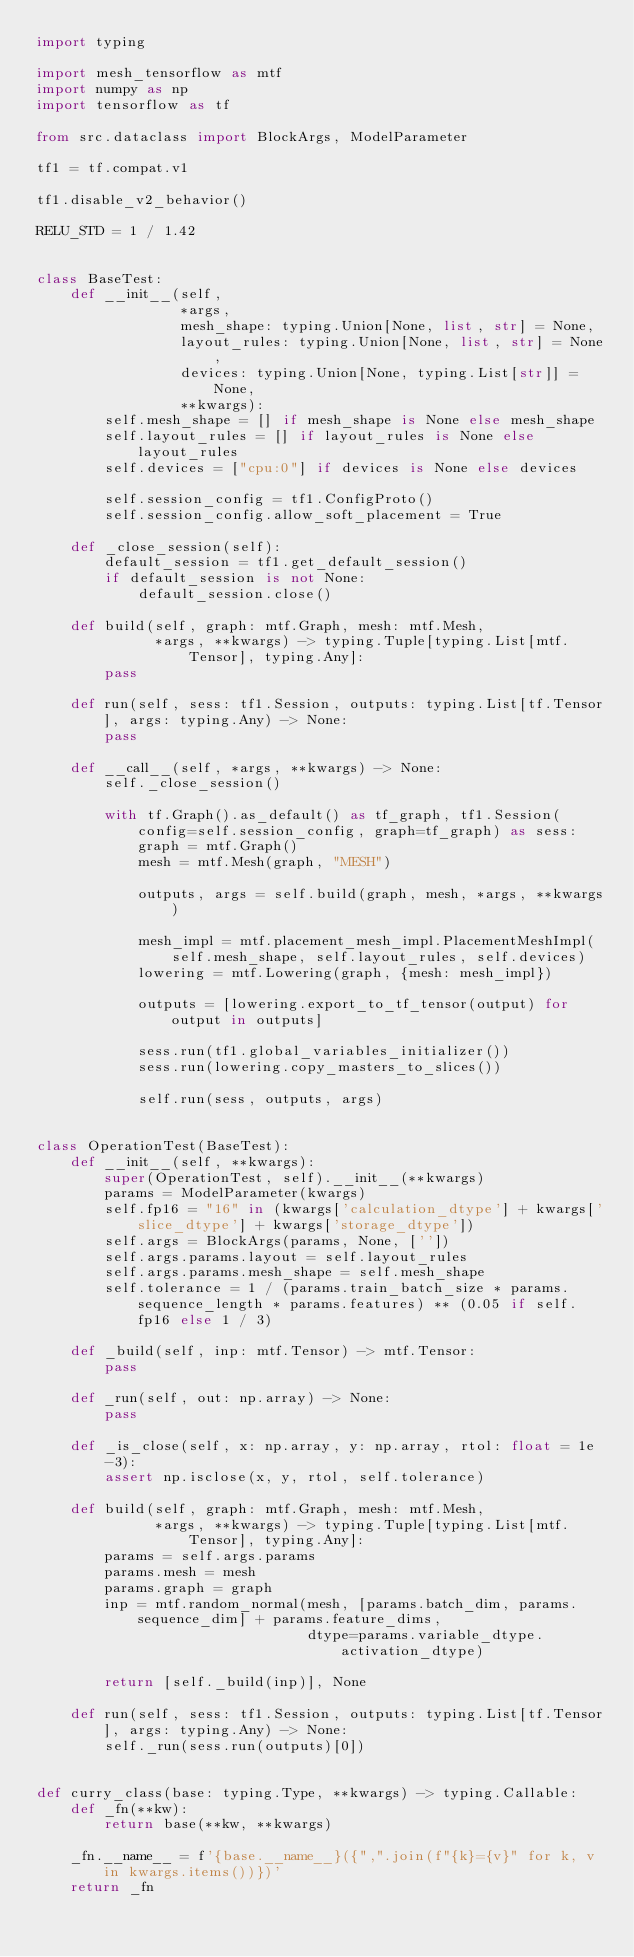<code> <loc_0><loc_0><loc_500><loc_500><_Python_>import typing

import mesh_tensorflow as mtf
import numpy as np
import tensorflow as tf

from src.dataclass import BlockArgs, ModelParameter

tf1 = tf.compat.v1

tf1.disable_v2_behavior()

RELU_STD = 1 / 1.42


class BaseTest:
    def __init__(self,
                 *args,
                 mesh_shape: typing.Union[None, list, str] = None,
                 layout_rules: typing.Union[None, list, str] = None,
                 devices: typing.Union[None, typing.List[str]] = None,
                 **kwargs):
        self.mesh_shape = [] if mesh_shape is None else mesh_shape
        self.layout_rules = [] if layout_rules is None else layout_rules
        self.devices = ["cpu:0"] if devices is None else devices

        self.session_config = tf1.ConfigProto()
        self.session_config.allow_soft_placement = True

    def _close_session(self):
        default_session = tf1.get_default_session()
        if default_session is not None:
            default_session.close()

    def build(self, graph: mtf.Graph, mesh: mtf.Mesh,
              *args, **kwargs) -> typing.Tuple[typing.List[mtf.Tensor], typing.Any]:
        pass

    def run(self, sess: tf1.Session, outputs: typing.List[tf.Tensor], args: typing.Any) -> None:
        pass

    def __call__(self, *args, **kwargs) -> None:
        self._close_session()

        with tf.Graph().as_default() as tf_graph, tf1.Session(config=self.session_config, graph=tf_graph) as sess:
            graph = mtf.Graph()
            mesh = mtf.Mesh(graph, "MESH")

            outputs, args = self.build(graph, mesh, *args, **kwargs)

            mesh_impl = mtf.placement_mesh_impl.PlacementMeshImpl(self.mesh_shape, self.layout_rules, self.devices)
            lowering = mtf.Lowering(graph, {mesh: mesh_impl})

            outputs = [lowering.export_to_tf_tensor(output) for output in outputs]

            sess.run(tf1.global_variables_initializer())
            sess.run(lowering.copy_masters_to_slices())

            self.run(sess, outputs, args)


class OperationTest(BaseTest):
    def __init__(self, **kwargs):
        super(OperationTest, self).__init__(**kwargs)
        params = ModelParameter(kwargs)
        self.fp16 = "16" in (kwargs['calculation_dtype'] + kwargs['slice_dtype'] + kwargs['storage_dtype'])
        self.args = BlockArgs(params, None, [''])
        self.args.params.layout = self.layout_rules
        self.args.params.mesh_shape = self.mesh_shape
        self.tolerance = 1 / (params.train_batch_size * params.sequence_length * params.features) ** (0.05 if self.fp16 else 1 / 3)

    def _build(self, inp: mtf.Tensor) -> mtf.Tensor:
        pass

    def _run(self, out: np.array) -> None:
        pass

    def _is_close(self, x: np.array, y: np.array, rtol: float = 1e-3):
        assert np.isclose(x, y, rtol, self.tolerance)

    def build(self, graph: mtf.Graph, mesh: mtf.Mesh,
              *args, **kwargs) -> typing.Tuple[typing.List[mtf.Tensor], typing.Any]:
        params = self.args.params
        params.mesh = mesh
        params.graph = graph
        inp = mtf.random_normal(mesh, [params.batch_dim, params.sequence_dim] + params.feature_dims,
                                dtype=params.variable_dtype.activation_dtype)

        return [self._build(inp)], None

    def run(self, sess: tf1.Session, outputs: typing.List[tf.Tensor], args: typing.Any) -> None:
        self._run(sess.run(outputs)[0])


def curry_class(base: typing.Type, **kwargs) -> typing.Callable:
    def _fn(**kw):
        return base(**kw, **kwargs)

    _fn.__name__ = f'{base.__name__}({",".join(f"{k}={v}" for k, v in kwargs.items())})'
    return _fn
</code> 